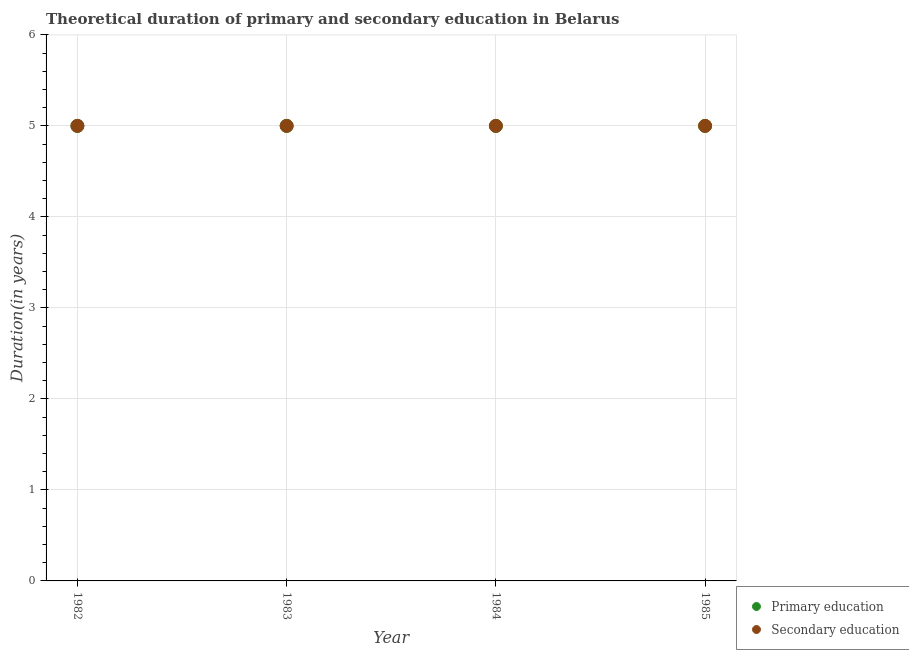How many different coloured dotlines are there?
Your response must be concise. 2. Is the number of dotlines equal to the number of legend labels?
Make the answer very short. Yes. What is the duration of primary education in 1984?
Make the answer very short. 5. Across all years, what is the maximum duration of secondary education?
Provide a short and direct response. 5. Across all years, what is the minimum duration of secondary education?
Keep it short and to the point. 5. In which year was the duration of secondary education maximum?
Your answer should be compact. 1982. In which year was the duration of primary education minimum?
Your answer should be compact. 1982. What is the total duration of primary education in the graph?
Provide a short and direct response. 20. What is the difference between the duration of secondary education in 1983 and that in 1984?
Give a very brief answer. 0. What is the difference between the duration of secondary education in 1985 and the duration of primary education in 1984?
Your response must be concise. 0. What is the average duration of primary education per year?
Give a very brief answer. 5. In how many years, is the duration of primary education greater than 4.8 years?
Keep it short and to the point. 4. Is the difference between the duration of primary education in 1982 and 1984 greater than the difference between the duration of secondary education in 1982 and 1984?
Make the answer very short. No. Is the sum of the duration of primary education in 1983 and 1985 greater than the maximum duration of secondary education across all years?
Your response must be concise. Yes. Does the duration of primary education monotonically increase over the years?
Make the answer very short. No. Is the duration of secondary education strictly greater than the duration of primary education over the years?
Your response must be concise. No. How many years are there in the graph?
Offer a terse response. 4. What is the difference between two consecutive major ticks on the Y-axis?
Make the answer very short. 1. Are the values on the major ticks of Y-axis written in scientific E-notation?
Your answer should be very brief. No. Does the graph contain any zero values?
Provide a succinct answer. No. What is the title of the graph?
Your response must be concise. Theoretical duration of primary and secondary education in Belarus. Does "Male labor force" appear as one of the legend labels in the graph?
Give a very brief answer. No. What is the label or title of the Y-axis?
Your answer should be very brief. Duration(in years). What is the Duration(in years) of Primary education in 1982?
Give a very brief answer. 5. What is the Duration(in years) of Secondary education in 1982?
Offer a terse response. 5. What is the Duration(in years) of Primary education in 1983?
Ensure brevity in your answer.  5. What is the Duration(in years) in Secondary education in 1985?
Make the answer very short. 5. Across all years, what is the maximum Duration(in years) in Secondary education?
Ensure brevity in your answer.  5. Across all years, what is the minimum Duration(in years) in Primary education?
Your answer should be compact. 5. What is the difference between the Duration(in years) in Secondary education in 1982 and that in 1983?
Keep it short and to the point. 0. What is the difference between the Duration(in years) in Primary education in 1982 and that in 1984?
Your answer should be very brief. 0. What is the difference between the Duration(in years) of Secondary education in 1982 and that in 1984?
Keep it short and to the point. 0. What is the difference between the Duration(in years) of Primary education in 1982 and that in 1985?
Your answer should be very brief. 0. What is the difference between the Duration(in years) of Primary education in 1983 and that in 1984?
Your response must be concise. 0. What is the difference between the Duration(in years) in Secondary education in 1983 and that in 1984?
Your response must be concise. 0. What is the difference between the Duration(in years) in Primary education in 1983 and that in 1985?
Provide a short and direct response. 0. What is the difference between the Duration(in years) of Secondary education in 1983 and that in 1985?
Your answer should be compact. 0. What is the difference between the Duration(in years) in Secondary education in 1984 and that in 1985?
Offer a terse response. 0. What is the difference between the Duration(in years) of Primary education in 1982 and the Duration(in years) of Secondary education in 1983?
Provide a short and direct response. 0. What is the difference between the Duration(in years) in Primary education in 1982 and the Duration(in years) in Secondary education in 1985?
Keep it short and to the point. 0. What is the difference between the Duration(in years) in Primary education in 1983 and the Duration(in years) in Secondary education in 1984?
Ensure brevity in your answer.  0. In the year 1982, what is the difference between the Duration(in years) in Primary education and Duration(in years) in Secondary education?
Offer a terse response. 0. In the year 1984, what is the difference between the Duration(in years) of Primary education and Duration(in years) of Secondary education?
Provide a succinct answer. 0. What is the ratio of the Duration(in years) in Primary education in 1982 to that in 1983?
Provide a short and direct response. 1. What is the ratio of the Duration(in years) of Secondary education in 1982 to that in 1984?
Provide a short and direct response. 1. What is the ratio of the Duration(in years) in Primary education in 1983 to that in 1984?
Make the answer very short. 1. What is the ratio of the Duration(in years) in Primary education in 1983 to that in 1985?
Give a very brief answer. 1. What is the difference between the highest and the second highest Duration(in years) of Primary education?
Provide a succinct answer. 0. What is the difference between the highest and the second highest Duration(in years) of Secondary education?
Your answer should be very brief. 0. What is the difference between the highest and the lowest Duration(in years) of Primary education?
Provide a succinct answer. 0. What is the difference between the highest and the lowest Duration(in years) of Secondary education?
Your response must be concise. 0. 